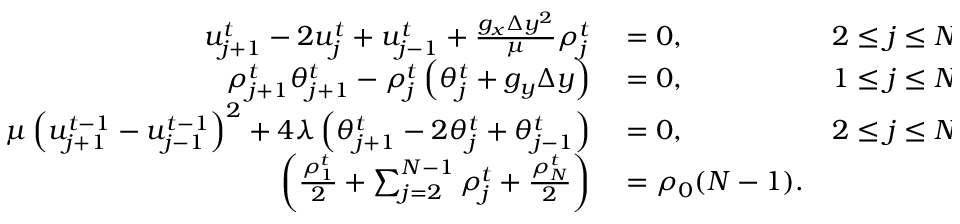Convert formula to latex. <formula><loc_0><loc_0><loc_500><loc_500>\begin{array} { r l r } { u _ { j + 1 } ^ { t } - 2 u _ { j } ^ { t } + u _ { j - 1 } ^ { t } + \frac { g _ { x } \Delta y ^ { 2 } } { \mu } \rho _ { j } ^ { t } } & = 0 , \quad } & { 2 \leq j \leq N - 1 , } \\ { \rho _ { j + 1 } ^ { t } \theta _ { j + 1 } ^ { t } - \rho _ { j } ^ { t } \left ( \theta _ { j } ^ { t } + g _ { y } \Delta y \right ) } & = 0 , \quad } & { 1 \leq j \leq N - 1 , } \\ { \mu \left ( u _ { j + 1 } ^ { t - 1 } - u _ { j - 1 } ^ { t - 1 } \right ) ^ { 2 } + 4 \lambda \left ( \theta _ { j + 1 } ^ { t } - 2 \theta _ { j } ^ { t } + \theta _ { j - 1 } ^ { t } \right ) } & = 0 , \quad } & { 2 \leq j \leq N - 1 , } \\ { \left ( \frac { \rho _ { 1 } ^ { t } } { 2 } + \sum _ { j = 2 } ^ { N - 1 } \rho _ { j } ^ { t } + \frac { \rho _ { N } ^ { t } } { 2 } \right ) } & = \rho _ { 0 } ( N - 1 ) . } \end{array}</formula> 